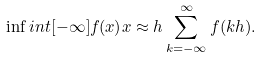Convert formula to latex. <formula><loc_0><loc_0><loc_500><loc_500>\inf i n t [ - \infty ] { f ( x ) } { x } \approx h \sum _ { k = - \infty } ^ { \infty } f ( k h ) .</formula> 